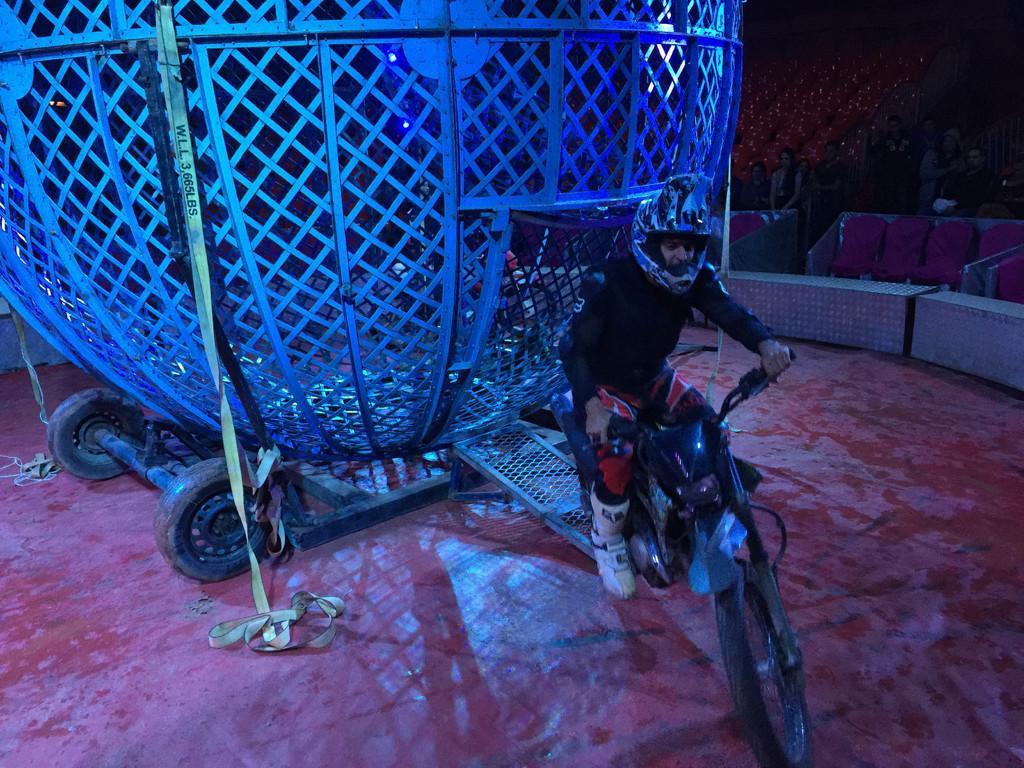How would you summarize this image in a sentence or two? This image is clicked outside. There is a cycle and a person is sitting on that cycle. He is wearing a helmet. There is something behind him. 